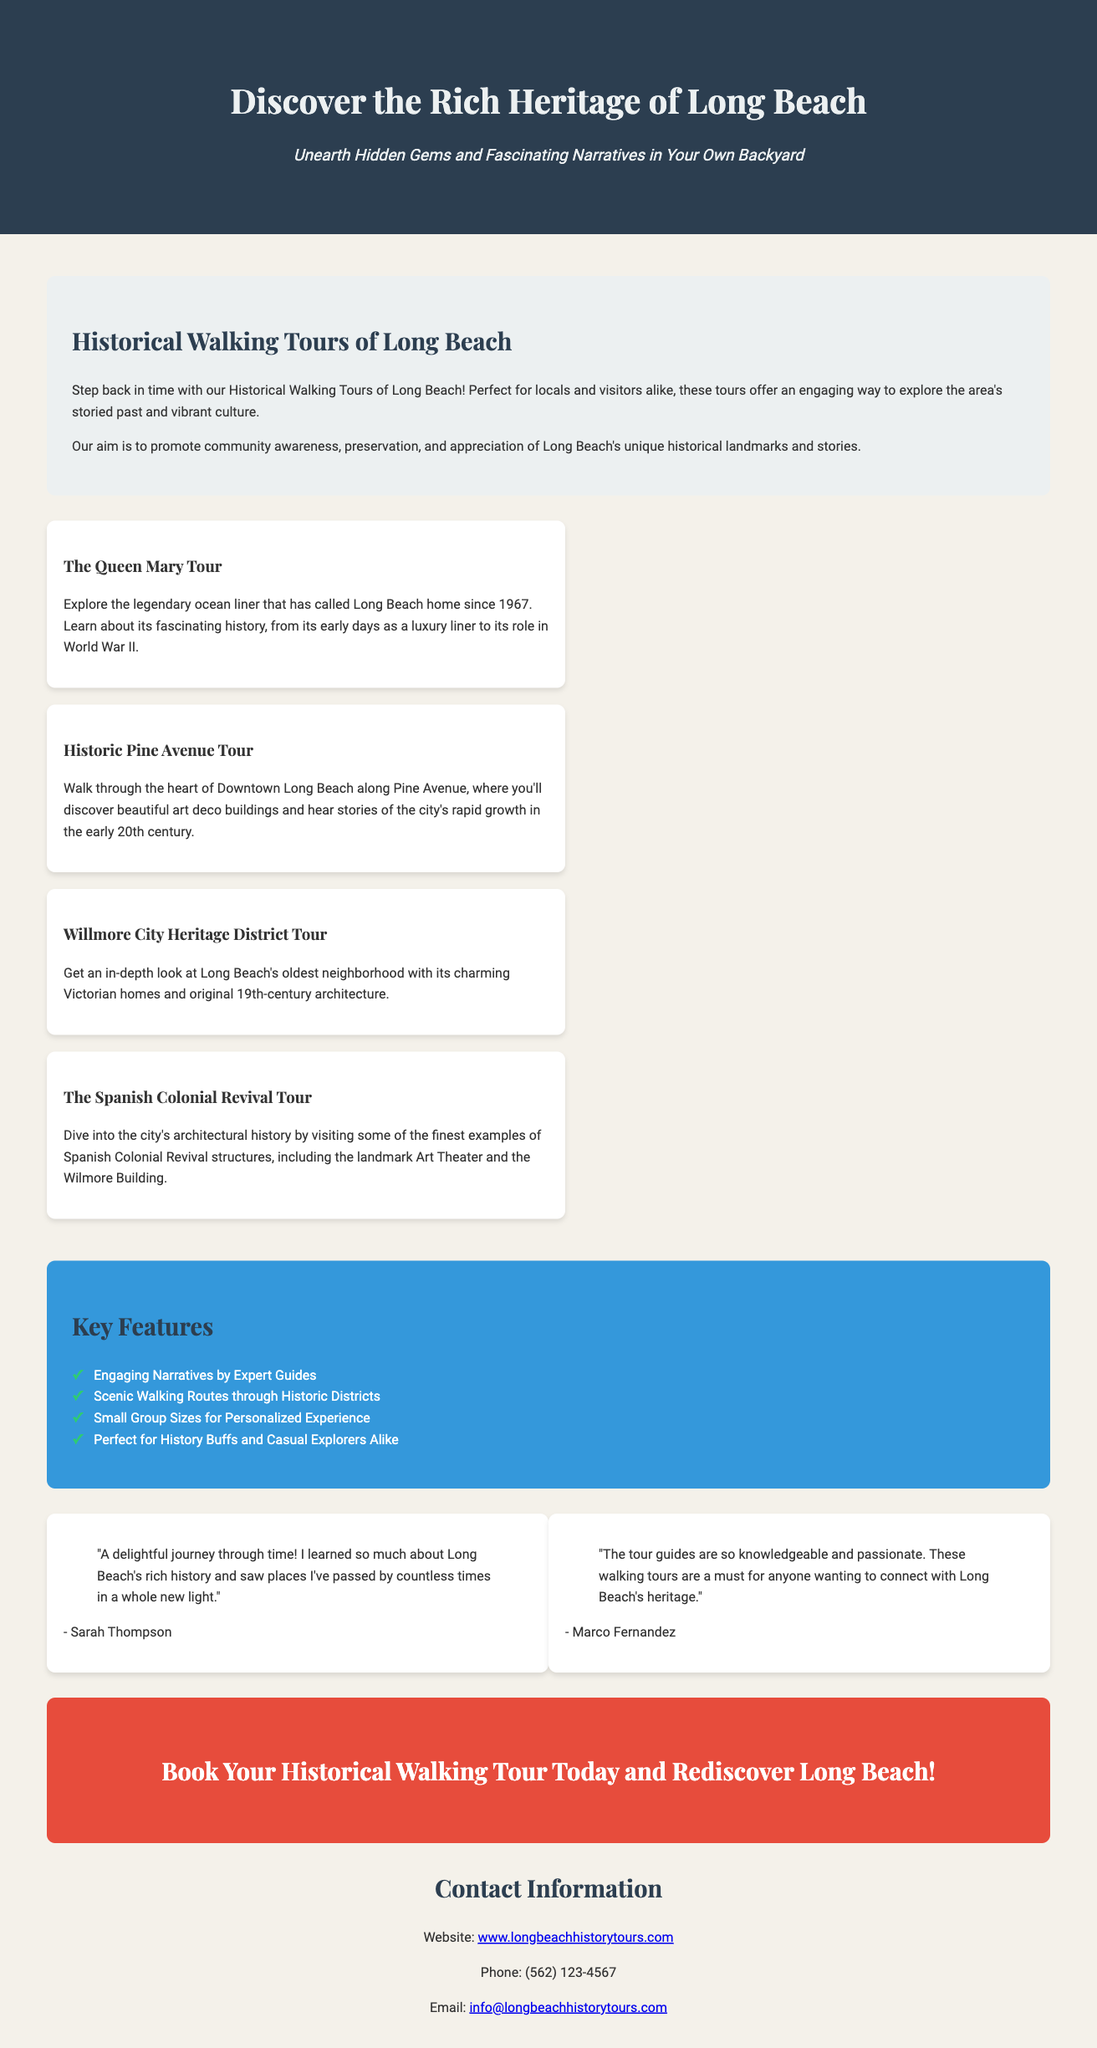What is the title of the advertisement? The title of the advertisement is displayed prominently at the top of the document.
Answer: Discover the Rich Heritage of Long Beach What is the subheadline of the advertisement? The subheadline provides additional context and interest, located below the title.
Answer: Unearth Hidden Gems and Fascinating Narratives in Your Own Backyard How many tours are featured in the advertisement? The document lists four tours in the tours section.
Answer: Four What is the first tour mentioned? The first tour listed provides the title and a brief description of its significance.
Answer: The Queen Mary Tour What is one key feature of the tours? The key features of the tours emphasize the engaging experience and structure of the tours, as listed in the features section.
Answer: Engaging Narratives by Expert Guides Who is one of the testimonials from? This information identifies a person who shared their experience about the tours in the testimonials section.
Answer: Sarah Thompson What is the contact phone number provided? The document includes contact information, including a phone number for inquiries about the tours.
Answer: (562) 123-4567 What kind of experiences do the walking tours cater to? The advertisement describes the target audience for the walking tours throughout the document.
Answer: History Buffs and Casual Explorers What call to action is included in the advertisement? The call to action encourages immediate engagement with the service offered in the advertisement.
Answer: Book Your Historical Walking Tour Today and Rediscover Long Beach! 